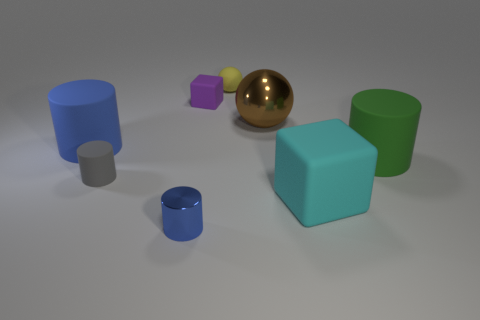How many other objects are there of the same material as the large block?
Provide a short and direct response. 5. There is a tiny thing that is in front of the brown metal sphere and behind the blue metallic thing; what is its color?
Ensure brevity in your answer.  Gray. What number of things are either matte cubes left of the small yellow sphere or large red cylinders?
Ensure brevity in your answer.  1. What number of other objects are there of the same color as the small metallic cylinder?
Offer a terse response. 1. Are there an equal number of large metal balls that are to the left of the small yellow rubber object and big purple rubber blocks?
Offer a terse response. Yes. There is a block that is behind the large cylinder that is to the right of the tiny purple rubber cube; how many small matte cylinders are on the right side of it?
Provide a short and direct response. 0. Is there anything else that is the same size as the shiny cylinder?
Your answer should be compact. Yes. Do the purple rubber block and the gray cylinder that is to the left of the small ball have the same size?
Make the answer very short. Yes. What number of large cyan objects are there?
Keep it short and to the point. 1. There is a blue object that is in front of the blue matte cylinder; is it the same size as the cylinder that is right of the tiny yellow ball?
Offer a terse response. No. 